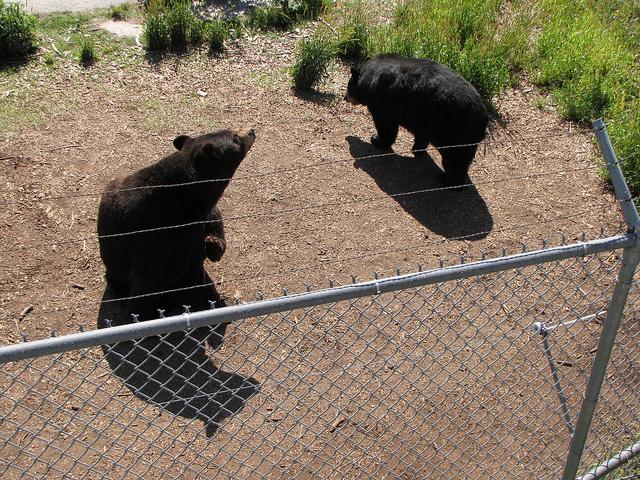How many bears are there?
Concise answer only. 2. How much metal is used to make the fence?
Quick response, please. Lot. Are the bears walking towards each other?
Give a very brief answer. No. Is this a zoo?
Write a very short answer. Yes. 